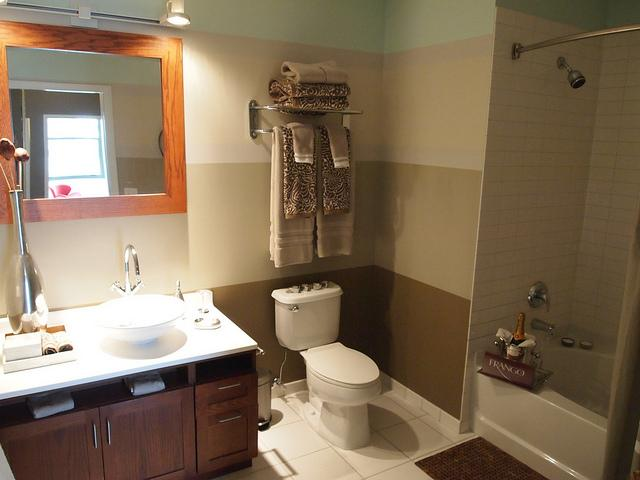What is on the rack sitting on the bathtub's edge? wine 